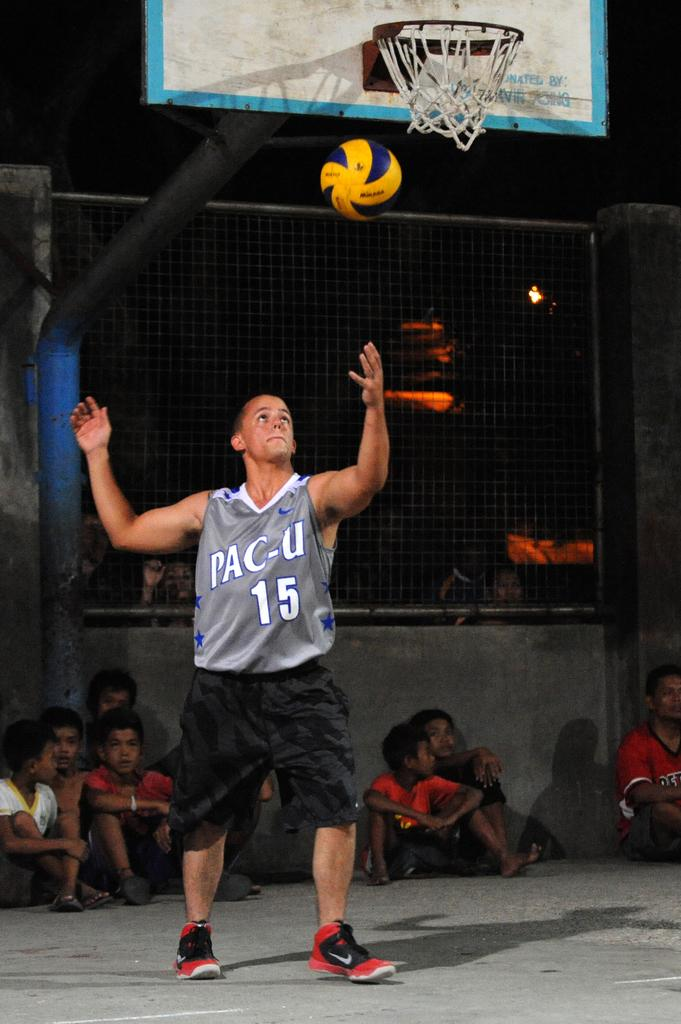<image>
Present a compact description of the photo's key features. A man wearing a PAC-U shirt throws a ball in the air as children sit around him. 